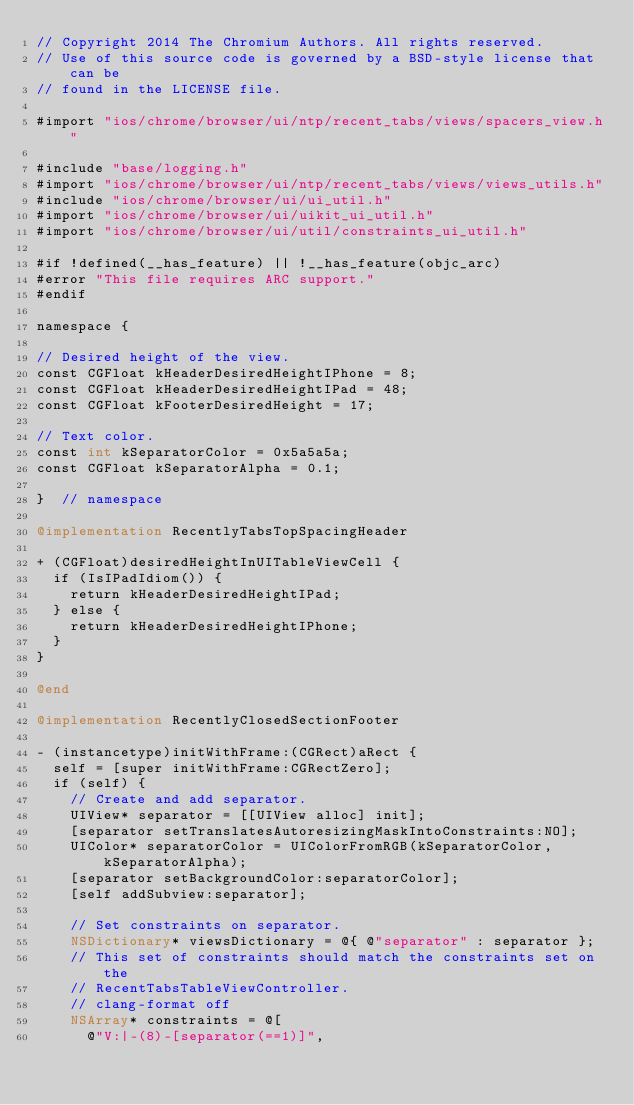<code> <loc_0><loc_0><loc_500><loc_500><_ObjectiveC_>// Copyright 2014 The Chromium Authors. All rights reserved.
// Use of this source code is governed by a BSD-style license that can be
// found in the LICENSE file.

#import "ios/chrome/browser/ui/ntp/recent_tabs/views/spacers_view.h"

#include "base/logging.h"
#import "ios/chrome/browser/ui/ntp/recent_tabs/views/views_utils.h"
#include "ios/chrome/browser/ui/ui_util.h"
#import "ios/chrome/browser/ui/uikit_ui_util.h"
#import "ios/chrome/browser/ui/util/constraints_ui_util.h"

#if !defined(__has_feature) || !__has_feature(objc_arc)
#error "This file requires ARC support."
#endif

namespace {

// Desired height of the view.
const CGFloat kHeaderDesiredHeightIPhone = 8;
const CGFloat kHeaderDesiredHeightIPad = 48;
const CGFloat kFooterDesiredHeight = 17;

// Text color.
const int kSeparatorColor = 0x5a5a5a;
const CGFloat kSeparatorAlpha = 0.1;

}  // namespace

@implementation RecentlyTabsTopSpacingHeader

+ (CGFloat)desiredHeightInUITableViewCell {
  if (IsIPadIdiom()) {
    return kHeaderDesiredHeightIPad;
  } else {
    return kHeaderDesiredHeightIPhone;
  }
}

@end

@implementation RecentlyClosedSectionFooter

- (instancetype)initWithFrame:(CGRect)aRect {
  self = [super initWithFrame:CGRectZero];
  if (self) {
    // Create and add separator.
    UIView* separator = [[UIView alloc] init];
    [separator setTranslatesAutoresizingMaskIntoConstraints:NO];
    UIColor* separatorColor = UIColorFromRGB(kSeparatorColor, kSeparatorAlpha);
    [separator setBackgroundColor:separatorColor];
    [self addSubview:separator];

    // Set constraints on separator.
    NSDictionary* viewsDictionary = @{ @"separator" : separator };
    // This set of constraints should match the constraints set on the
    // RecentTabsTableViewController.
    // clang-format off
    NSArray* constraints = @[
      @"V:|-(8)-[separator(==1)]",</code> 